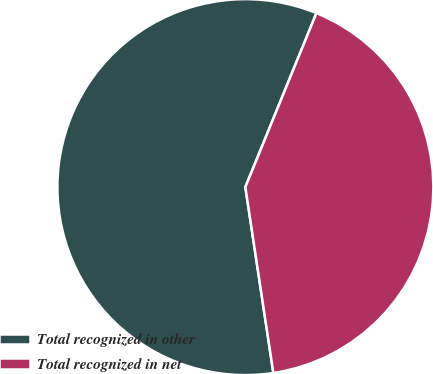Convert chart. <chart><loc_0><loc_0><loc_500><loc_500><pie_chart><fcel>Total recognized in other<fcel>Total recognized in net<nl><fcel>58.55%<fcel>41.45%<nl></chart> 